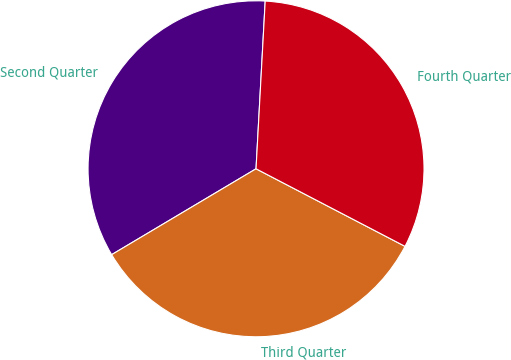<chart> <loc_0><loc_0><loc_500><loc_500><pie_chart><fcel>Second Quarter<fcel>Third Quarter<fcel>Fourth Quarter<nl><fcel>34.41%<fcel>33.82%<fcel>31.77%<nl></chart> 